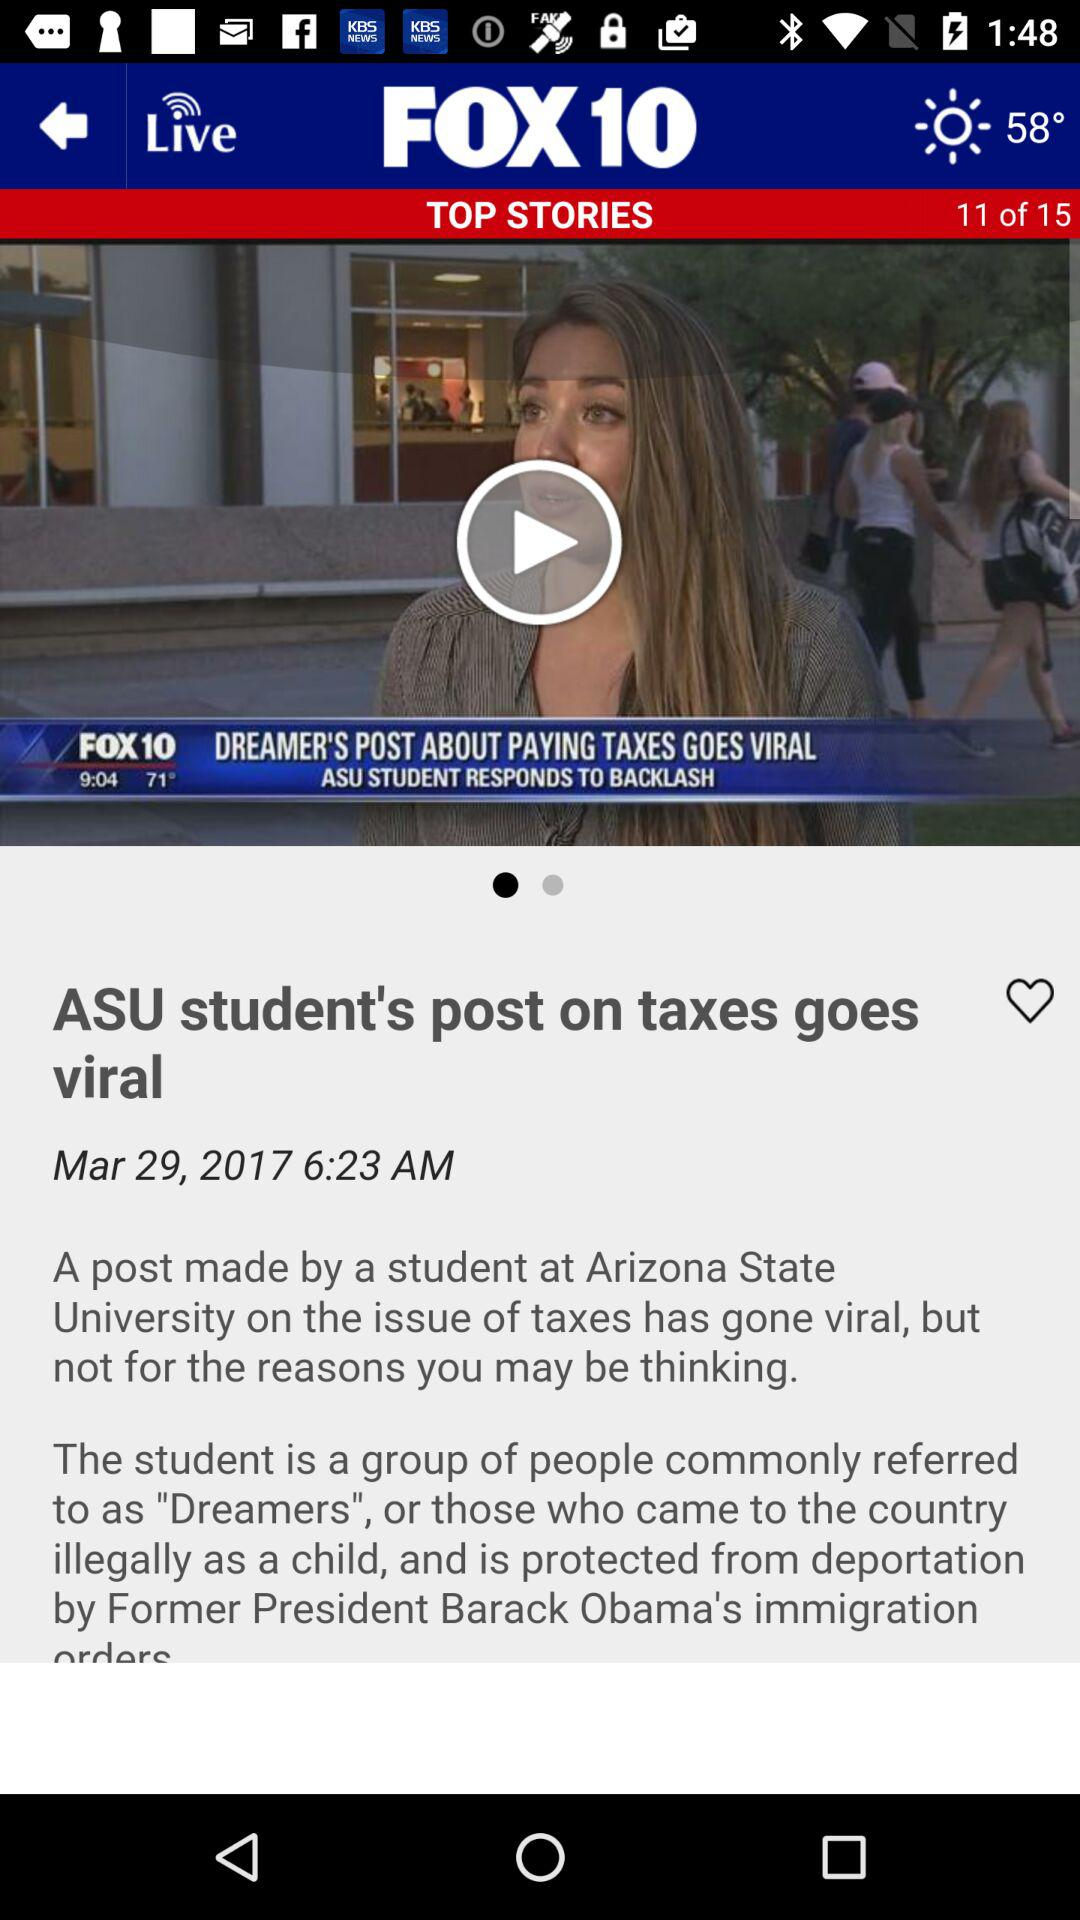What is the total number of stories? The total number of stories is 15. 